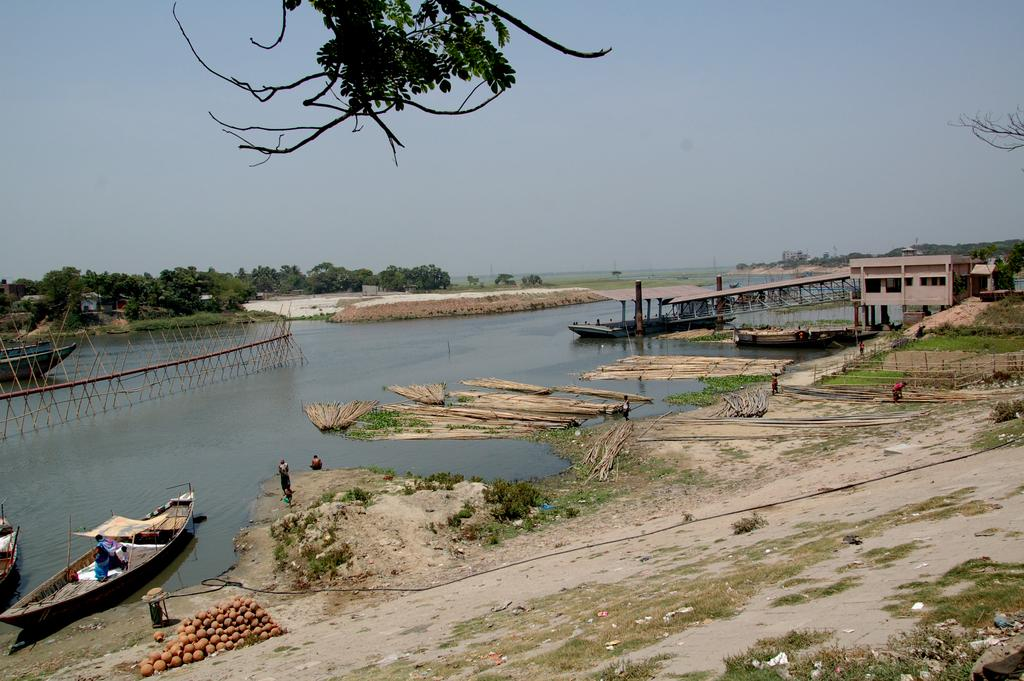What type of landscape is depicted in the image? The image contains land, a pond, and trees, indicating a natural landscape. What can be seen floating on the pond in the image? There are boats in the image. What type of containers are present in the image? There are pots in the image. What type of structure is visible in the image? There is a building in the image. What type of vegetation is present in the image? There are trees in the image. What type of people are visible in the image? There are humans in the image. What color is the sky in the image? The sky is blue in color. What part of a tree is present at the top of the image? A branch of a tree is present at the top of the image. What type of oil can be seen floating on the pond in the image? There is no oil present in the image; it features a pond with boats. What type of industry is depicted in the image? There is no industry depicted in the image; it features a natural landscape with a pond, trees, and a building. 